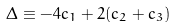Convert formula to latex. <formula><loc_0><loc_0><loc_500><loc_500>\Delta \equiv - 4 c _ { 1 } + 2 ( c _ { 2 } + c _ { 3 } )</formula> 